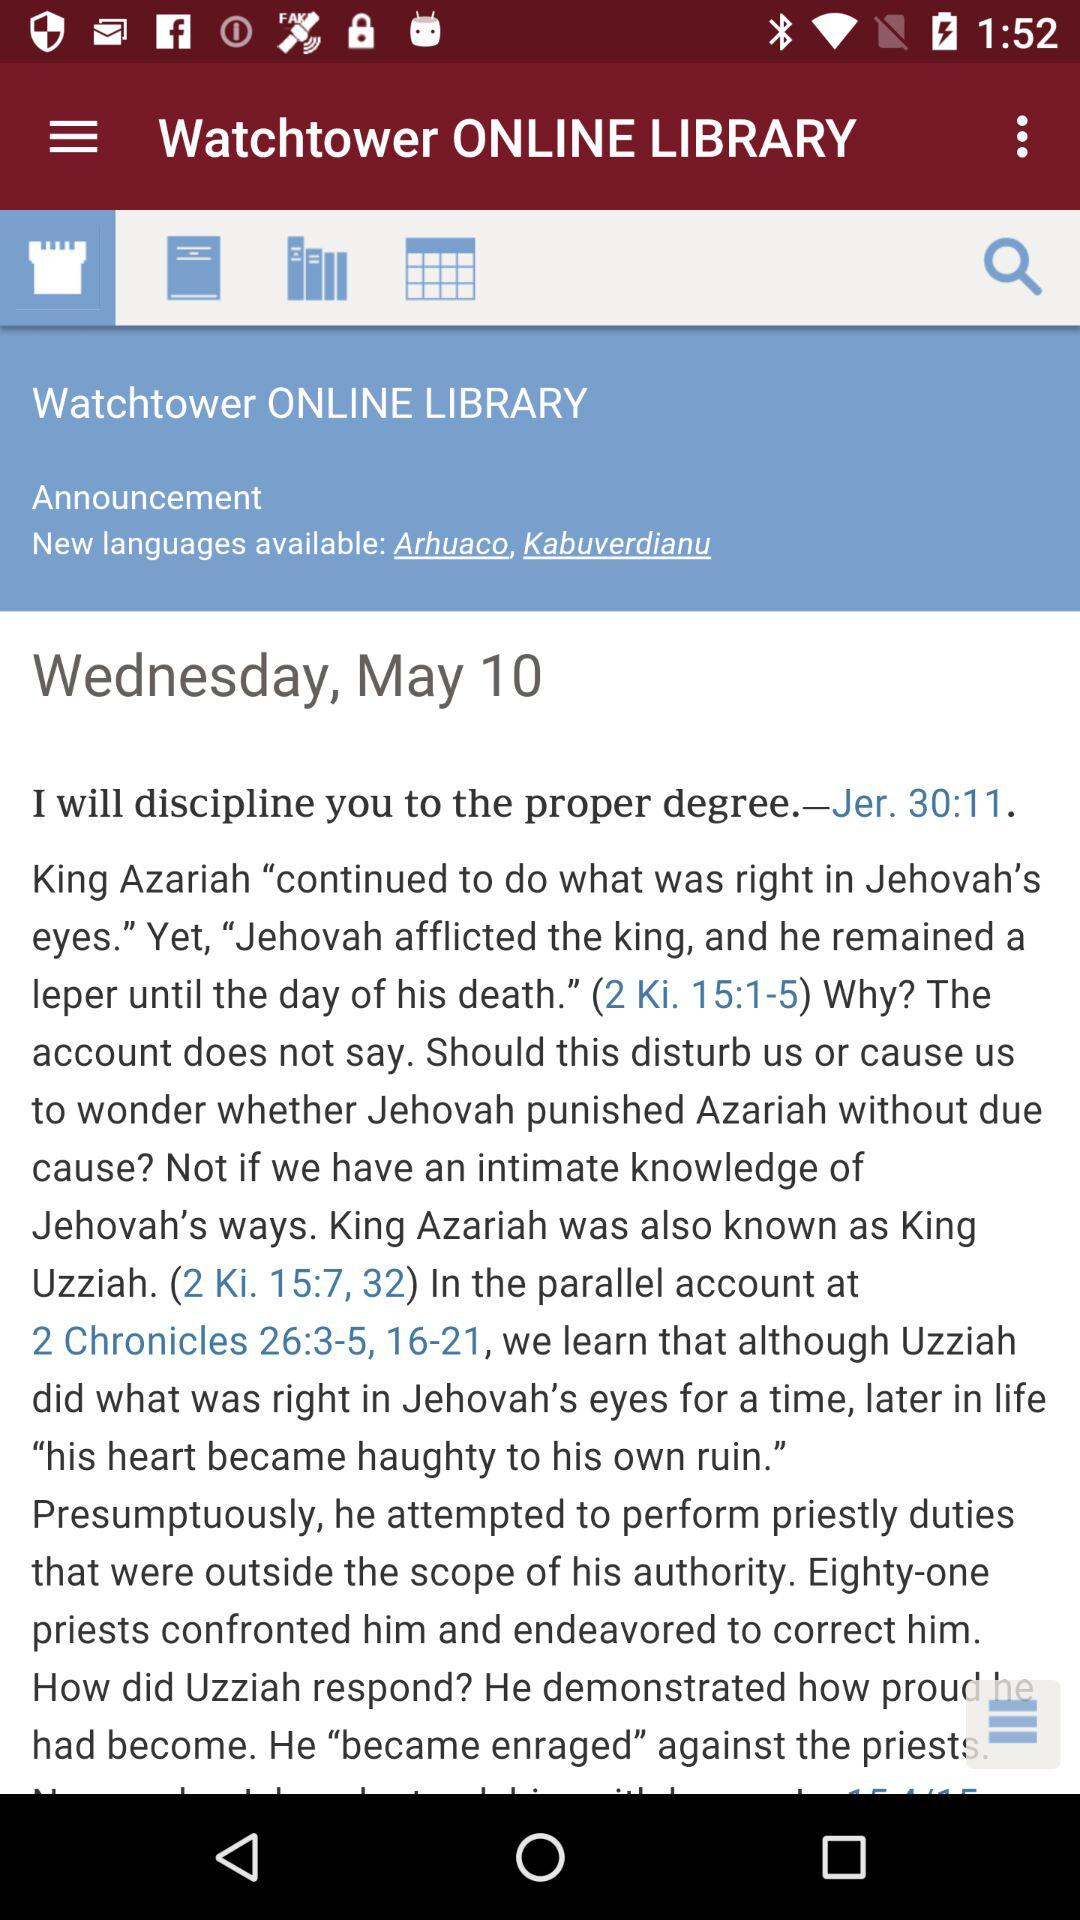What is the name of the application? The name of the application is "Watchtower ONLINE LIBRARY". 